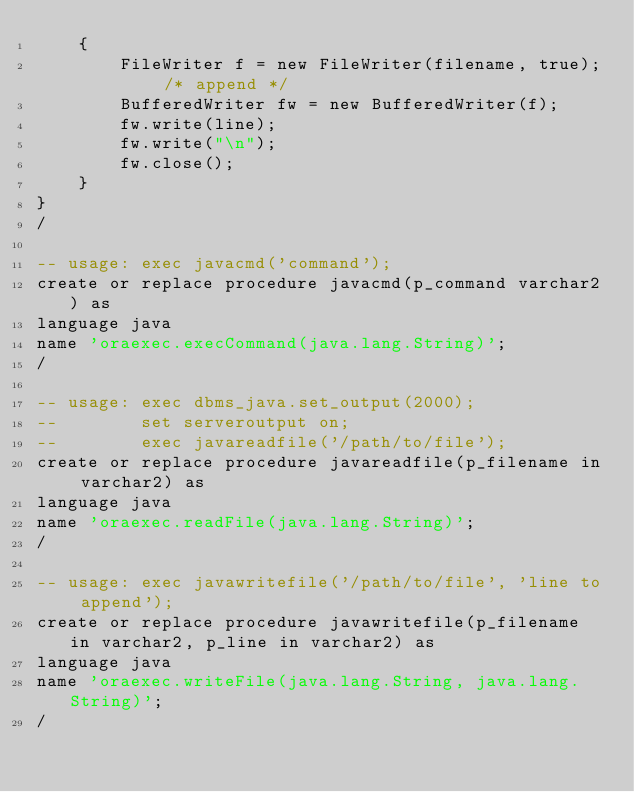<code> <loc_0><loc_0><loc_500><loc_500><_SQL_>	{
		FileWriter f = new FileWriter(filename, true); /* append */
		BufferedWriter fw = new BufferedWriter(f);
		fw.write(line);
		fw.write("\n");
		fw.close();
	}
}
/

-- usage: exec javacmd('command');
create or replace procedure javacmd(p_command varchar2) as
language java           
name 'oraexec.execCommand(java.lang.String)';
/

-- usage: exec dbms_java.set_output(2000);
--        set serveroutput on;
--        exec javareadfile('/path/to/file');
create or replace procedure javareadfile(p_filename in varchar2) as
language java
name 'oraexec.readFile(java.lang.String)';
/

-- usage: exec javawritefile('/path/to/file', 'line to append');
create or replace procedure javawritefile(p_filename in varchar2, p_line in varchar2) as
language java
name 'oraexec.writeFile(java.lang.String, java.lang.String)';
/
</code> 